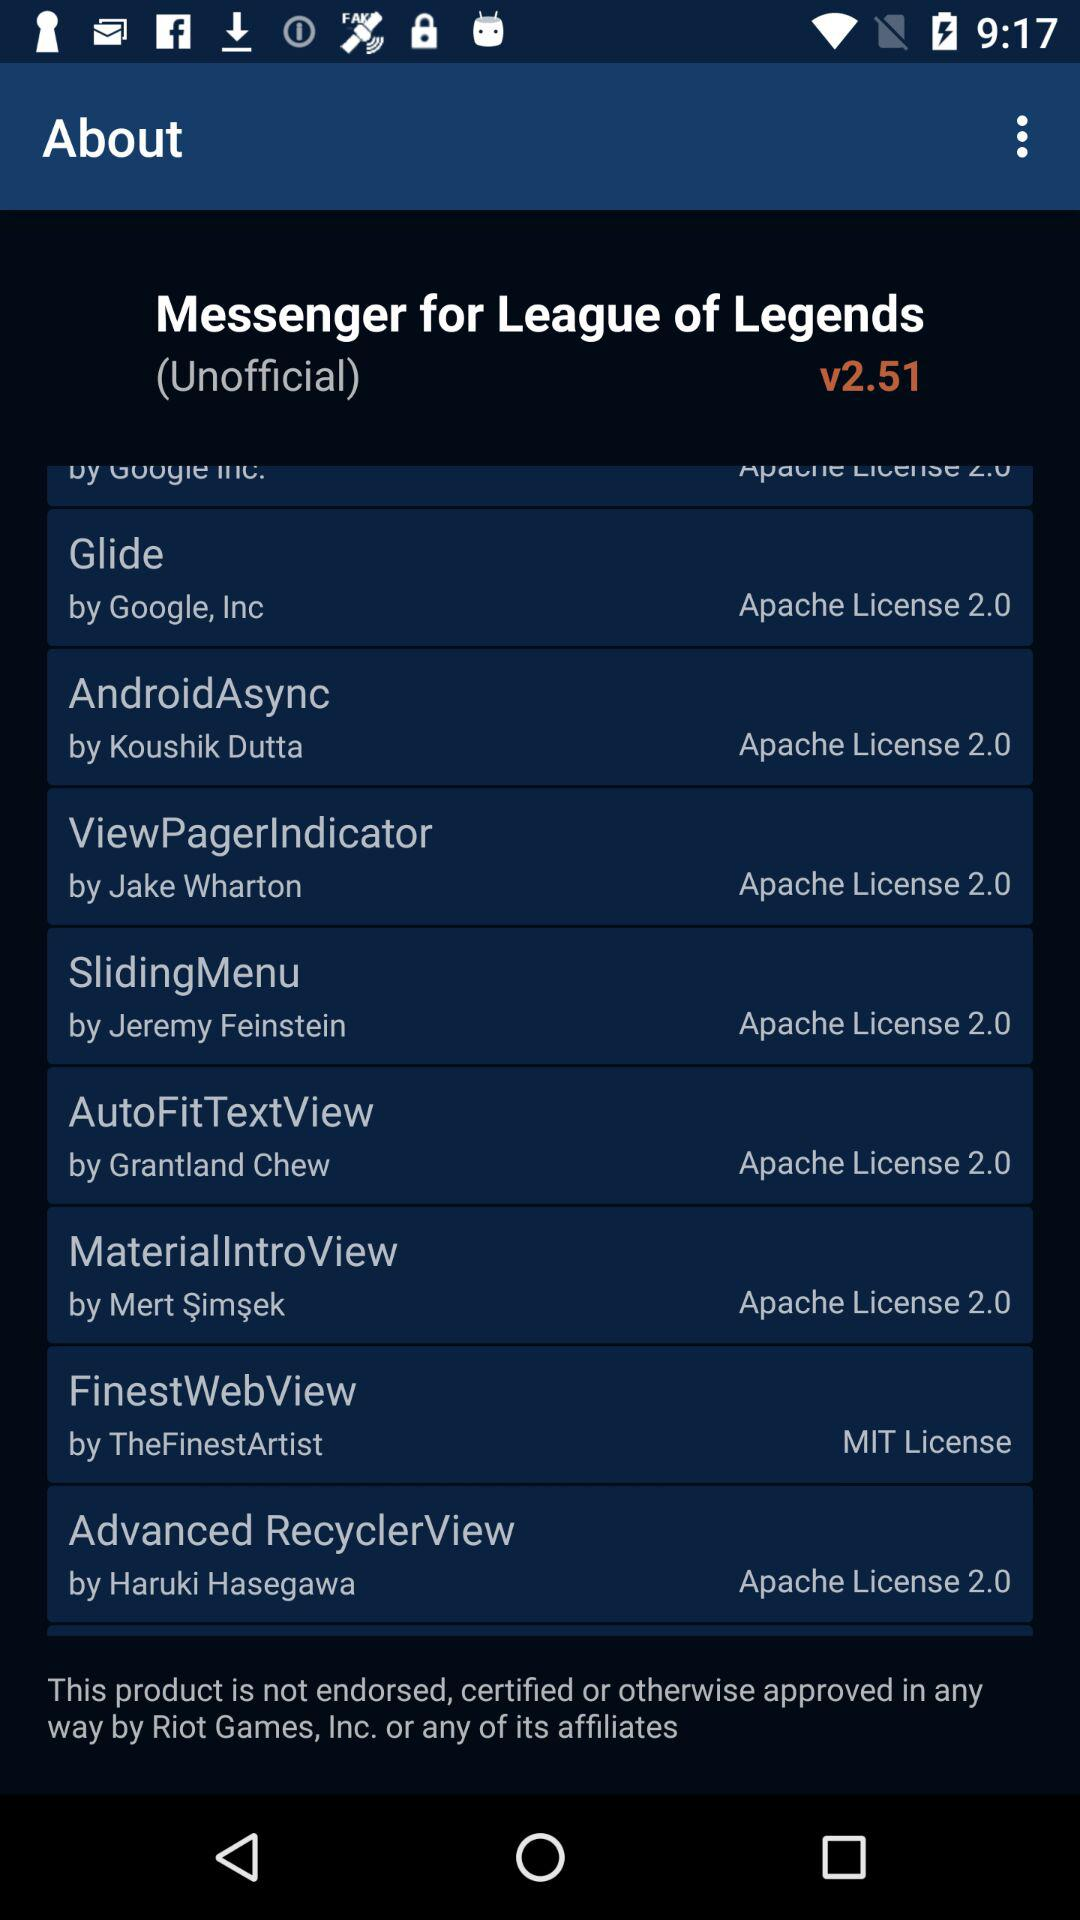What version is used? The used version is v2.51. 